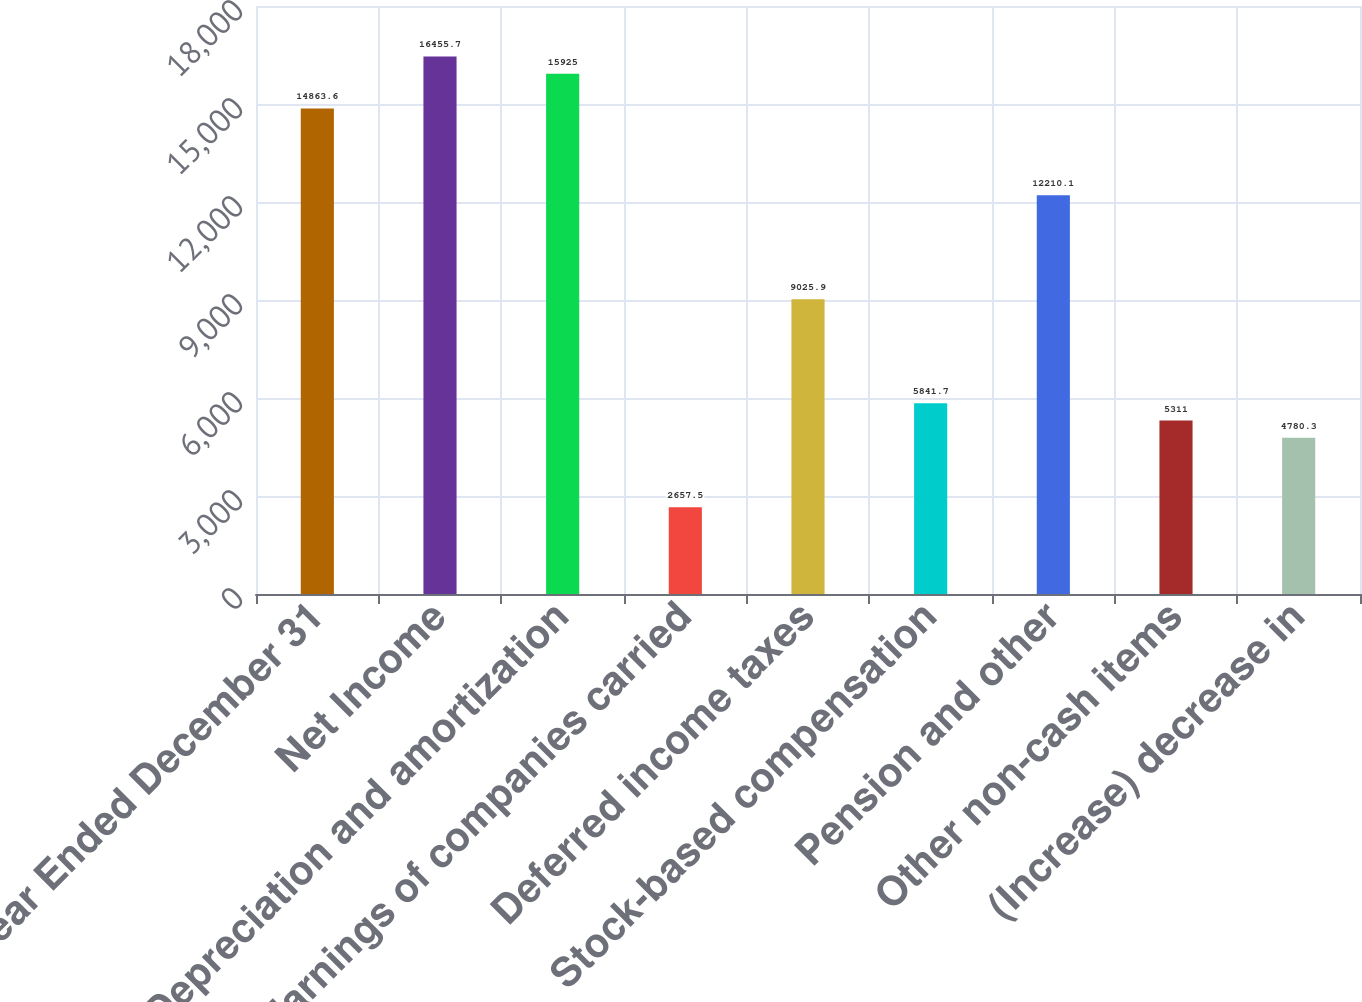<chart> <loc_0><loc_0><loc_500><loc_500><bar_chart><fcel>Year Ended December 31<fcel>Net Income<fcel>Depreciation and amortization<fcel>Earnings of companies carried<fcel>Deferred income taxes<fcel>Stock-based compensation<fcel>Pension and other<fcel>Other non-cash items<fcel>(Increase) decrease in<nl><fcel>14863.6<fcel>16455.7<fcel>15925<fcel>2657.5<fcel>9025.9<fcel>5841.7<fcel>12210.1<fcel>5311<fcel>4780.3<nl></chart> 